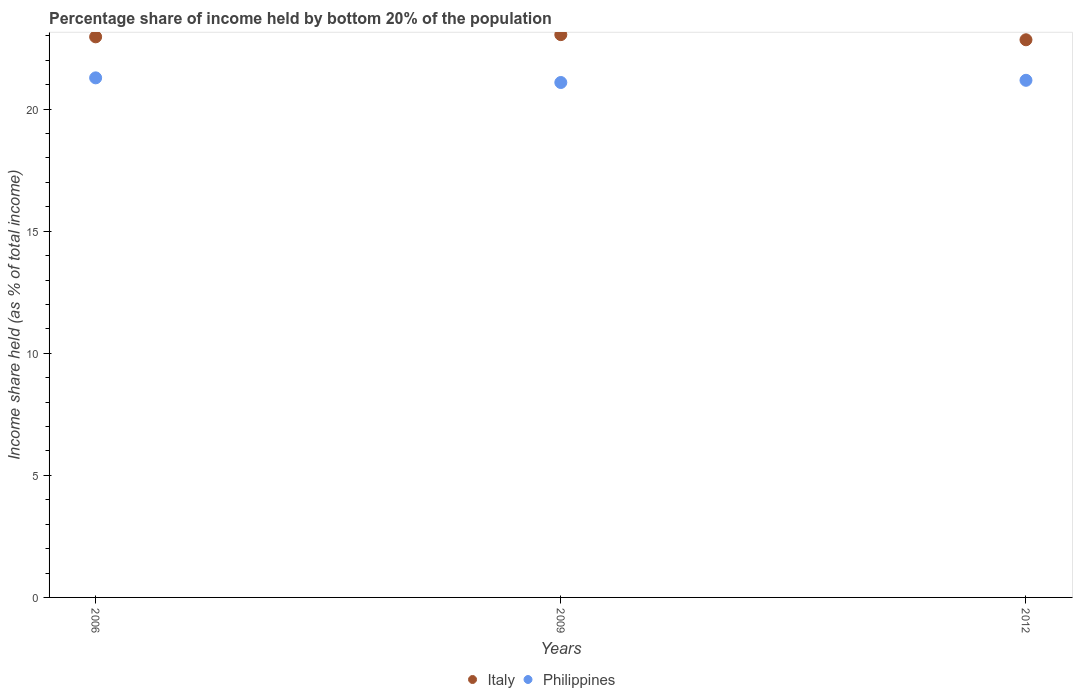How many different coloured dotlines are there?
Your answer should be compact. 2. What is the share of income held by bottom 20% of the population in Italy in 2012?
Give a very brief answer. 22.84. Across all years, what is the maximum share of income held by bottom 20% of the population in Italy?
Provide a short and direct response. 23.05. Across all years, what is the minimum share of income held by bottom 20% of the population in Italy?
Give a very brief answer. 22.84. What is the total share of income held by bottom 20% of the population in Italy in the graph?
Give a very brief answer. 68.85. What is the difference between the share of income held by bottom 20% of the population in Philippines in 2006 and that in 2012?
Your answer should be very brief. 0.1. What is the difference between the share of income held by bottom 20% of the population in Philippines in 2009 and the share of income held by bottom 20% of the population in Italy in 2012?
Offer a very short reply. -1.75. What is the average share of income held by bottom 20% of the population in Italy per year?
Your answer should be very brief. 22.95. In the year 2009, what is the difference between the share of income held by bottom 20% of the population in Philippines and share of income held by bottom 20% of the population in Italy?
Your answer should be very brief. -1.96. What is the ratio of the share of income held by bottom 20% of the population in Italy in 2009 to that in 2012?
Provide a succinct answer. 1.01. Is the difference between the share of income held by bottom 20% of the population in Philippines in 2006 and 2012 greater than the difference between the share of income held by bottom 20% of the population in Italy in 2006 and 2012?
Keep it short and to the point. No. What is the difference between the highest and the second highest share of income held by bottom 20% of the population in Philippines?
Make the answer very short. 0.1. What is the difference between the highest and the lowest share of income held by bottom 20% of the population in Philippines?
Provide a succinct answer. 0.19. Is the sum of the share of income held by bottom 20% of the population in Philippines in 2009 and 2012 greater than the maximum share of income held by bottom 20% of the population in Italy across all years?
Give a very brief answer. Yes. Is the share of income held by bottom 20% of the population in Italy strictly greater than the share of income held by bottom 20% of the population in Philippines over the years?
Make the answer very short. Yes. How many dotlines are there?
Ensure brevity in your answer.  2. How many years are there in the graph?
Your answer should be very brief. 3. What is the difference between two consecutive major ticks on the Y-axis?
Make the answer very short. 5. Does the graph contain grids?
Provide a succinct answer. No. How many legend labels are there?
Provide a succinct answer. 2. What is the title of the graph?
Your answer should be compact. Percentage share of income held by bottom 20% of the population. Does "Austria" appear as one of the legend labels in the graph?
Provide a short and direct response. No. What is the label or title of the X-axis?
Keep it short and to the point. Years. What is the label or title of the Y-axis?
Keep it short and to the point. Income share held (as % of total income). What is the Income share held (as % of total income) of Italy in 2006?
Give a very brief answer. 22.96. What is the Income share held (as % of total income) of Philippines in 2006?
Keep it short and to the point. 21.28. What is the Income share held (as % of total income) of Italy in 2009?
Provide a succinct answer. 23.05. What is the Income share held (as % of total income) in Philippines in 2009?
Offer a terse response. 21.09. What is the Income share held (as % of total income) of Italy in 2012?
Offer a very short reply. 22.84. What is the Income share held (as % of total income) of Philippines in 2012?
Offer a very short reply. 21.18. Across all years, what is the maximum Income share held (as % of total income) in Italy?
Your response must be concise. 23.05. Across all years, what is the maximum Income share held (as % of total income) in Philippines?
Your answer should be compact. 21.28. Across all years, what is the minimum Income share held (as % of total income) of Italy?
Your answer should be compact. 22.84. Across all years, what is the minimum Income share held (as % of total income) in Philippines?
Ensure brevity in your answer.  21.09. What is the total Income share held (as % of total income) of Italy in the graph?
Provide a short and direct response. 68.85. What is the total Income share held (as % of total income) in Philippines in the graph?
Provide a short and direct response. 63.55. What is the difference between the Income share held (as % of total income) in Italy in 2006 and that in 2009?
Make the answer very short. -0.09. What is the difference between the Income share held (as % of total income) of Philippines in 2006 and that in 2009?
Make the answer very short. 0.19. What is the difference between the Income share held (as % of total income) in Italy in 2006 and that in 2012?
Provide a succinct answer. 0.12. What is the difference between the Income share held (as % of total income) of Italy in 2009 and that in 2012?
Give a very brief answer. 0.21. What is the difference between the Income share held (as % of total income) in Philippines in 2009 and that in 2012?
Offer a terse response. -0.09. What is the difference between the Income share held (as % of total income) of Italy in 2006 and the Income share held (as % of total income) of Philippines in 2009?
Your answer should be very brief. 1.87. What is the difference between the Income share held (as % of total income) of Italy in 2006 and the Income share held (as % of total income) of Philippines in 2012?
Make the answer very short. 1.78. What is the difference between the Income share held (as % of total income) of Italy in 2009 and the Income share held (as % of total income) of Philippines in 2012?
Your answer should be very brief. 1.87. What is the average Income share held (as % of total income) in Italy per year?
Provide a short and direct response. 22.95. What is the average Income share held (as % of total income) of Philippines per year?
Make the answer very short. 21.18. In the year 2006, what is the difference between the Income share held (as % of total income) in Italy and Income share held (as % of total income) in Philippines?
Make the answer very short. 1.68. In the year 2009, what is the difference between the Income share held (as % of total income) of Italy and Income share held (as % of total income) of Philippines?
Offer a very short reply. 1.96. In the year 2012, what is the difference between the Income share held (as % of total income) in Italy and Income share held (as % of total income) in Philippines?
Make the answer very short. 1.66. What is the ratio of the Income share held (as % of total income) of Italy in 2006 to that in 2009?
Your answer should be very brief. 1. What is the ratio of the Income share held (as % of total income) in Italy in 2006 to that in 2012?
Keep it short and to the point. 1.01. What is the ratio of the Income share held (as % of total income) of Philippines in 2006 to that in 2012?
Provide a short and direct response. 1. What is the ratio of the Income share held (as % of total income) in Italy in 2009 to that in 2012?
Give a very brief answer. 1.01. What is the difference between the highest and the second highest Income share held (as % of total income) of Italy?
Your answer should be compact. 0.09. What is the difference between the highest and the lowest Income share held (as % of total income) of Italy?
Ensure brevity in your answer.  0.21. What is the difference between the highest and the lowest Income share held (as % of total income) of Philippines?
Offer a terse response. 0.19. 